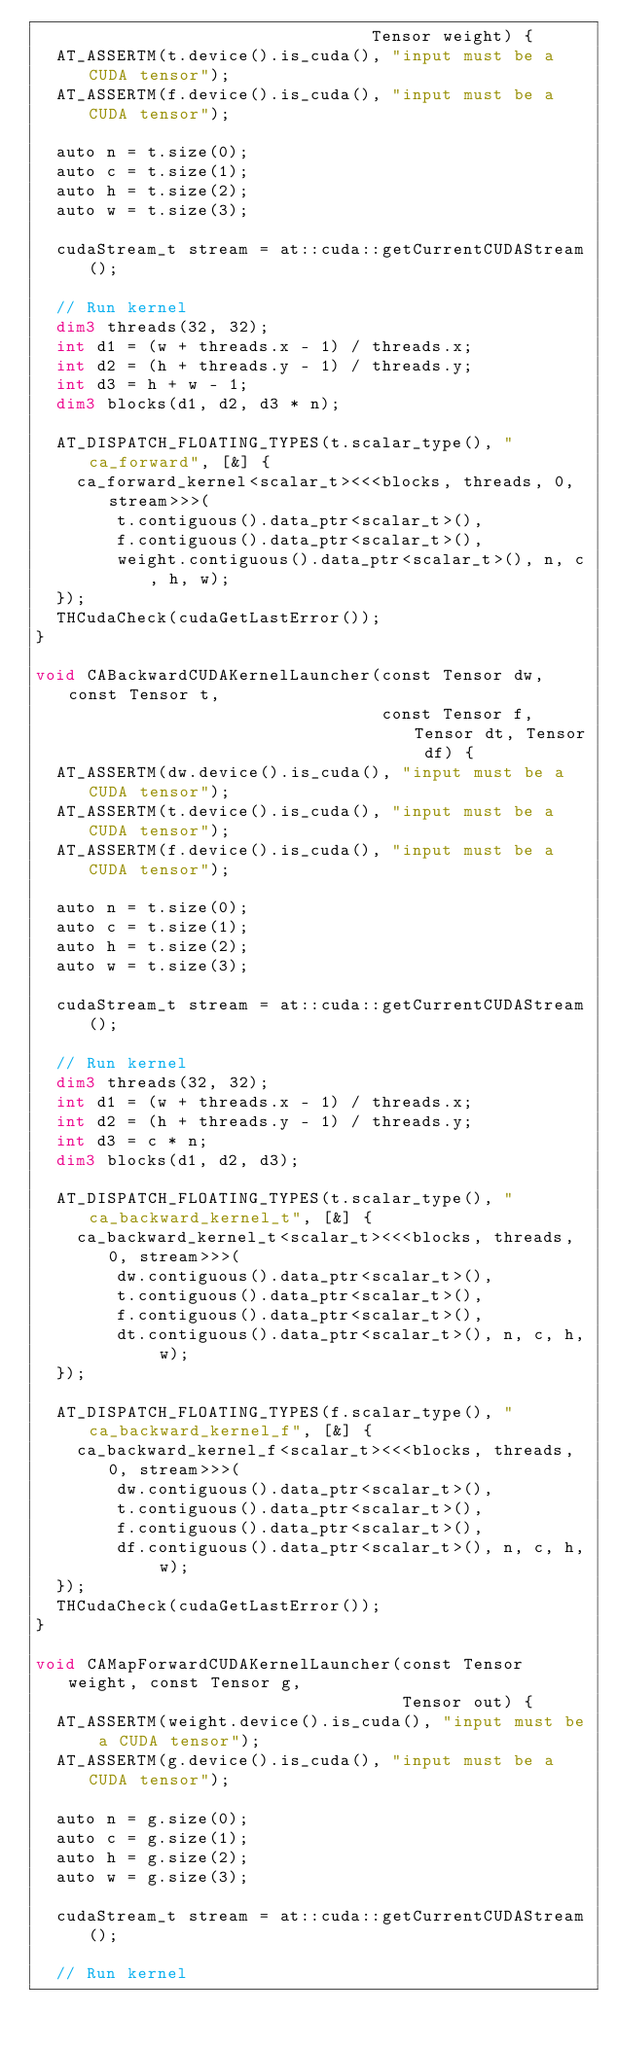Convert code to text. <code><loc_0><loc_0><loc_500><loc_500><_Cuda_>                                 Tensor weight) {
  AT_ASSERTM(t.device().is_cuda(), "input must be a CUDA tensor");
  AT_ASSERTM(f.device().is_cuda(), "input must be a CUDA tensor");

  auto n = t.size(0);
  auto c = t.size(1);
  auto h = t.size(2);
  auto w = t.size(3);

  cudaStream_t stream = at::cuda::getCurrentCUDAStream();

  // Run kernel
  dim3 threads(32, 32);
  int d1 = (w + threads.x - 1) / threads.x;
  int d2 = (h + threads.y - 1) / threads.y;
  int d3 = h + w - 1;
  dim3 blocks(d1, d2, d3 * n);

  AT_DISPATCH_FLOATING_TYPES(t.scalar_type(), "ca_forward", [&] {
    ca_forward_kernel<scalar_t><<<blocks, threads, 0, stream>>>(
        t.contiguous().data_ptr<scalar_t>(),
        f.contiguous().data_ptr<scalar_t>(),
        weight.contiguous().data_ptr<scalar_t>(), n, c, h, w);
  });
  THCudaCheck(cudaGetLastError());
}

void CABackwardCUDAKernelLauncher(const Tensor dw, const Tensor t,
                                  const Tensor f, Tensor dt, Tensor df) {
  AT_ASSERTM(dw.device().is_cuda(), "input must be a CUDA tensor");
  AT_ASSERTM(t.device().is_cuda(), "input must be a CUDA tensor");
  AT_ASSERTM(f.device().is_cuda(), "input must be a CUDA tensor");

  auto n = t.size(0);
  auto c = t.size(1);
  auto h = t.size(2);
  auto w = t.size(3);

  cudaStream_t stream = at::cuda::getCurrentCUDAStream();

  // Run kernel
  dim3 threads(32, 32);
  int d1 = (w + threads.x - 1) / threads.x;
  int d2 = (h + threads.y - 1) / threads.y;
  int d3 = c * n;
  dim3 blocks(d1, d2, d3);

  AT_DISPATCH_FLOATING_TYPES(t.scalar_type(), "ca_backward_kernel_t", [&] {
    ca_backward_kernel_t<scalar_t><<<blocks, threads, 0, stream>>>(
        dw.contiguous().data_ptr<scalar_t>(),
        t.contiguous().data_ptr<scalar_t>(),
        f.contiguous().data_ptr<scalar_t>(),
        dt.contiguous().data_ptr<scalar_t>(), n, c, h, w);
  });

  AT_DISPATCH_FLOATING_TYPES(f.scalar_type(), "ca_backward_kernel_f", [&] {
    ca_backward_kernel_f<scalar_t><<<blocks, threads, 0, stream>>>(
        dw.contiguous().data_ptr<scalar_t>(),
        t.contiguous().data_ptr<scalar_t>(),
        f.contiguous().data_ptr<scalar_t>(),
        df.contiguous().data_ptr<scalar_t>(), n, c, h, w);
  });
  THCudaCheck(cudaGetLastError());
}

void CAMapForwardCUDAKernelLauncher(const Tensor weight, const Tensor g,
                                    Tensor out) {
  AT_ASSERTM(weight.device().is_cuda(), "input must be a CUDA tensor");
  AT_ASSERTM(g.device().is_cuda(), "input must be a CUDA tensor");

  auto n = g.size(0);
  auto c = g.size(1);
  auto h = g.size(2);
  auto w = g.size(3);

  cudaStream_t stream = at::cuda::getCurrentCUDAStream();

  // Run kernel</code> 